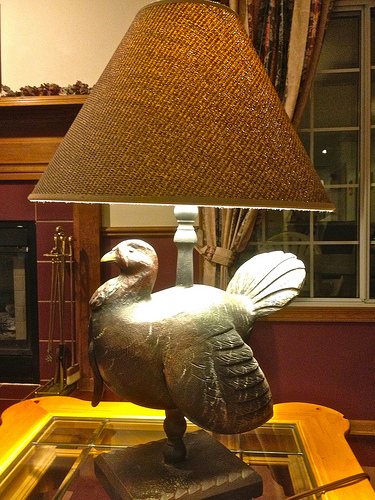<image>
Is the lampshade to the left of the turkey? No. The lampshade is not to the left of the turkey. From this viewpoint, they have a different horizontal relationship. 